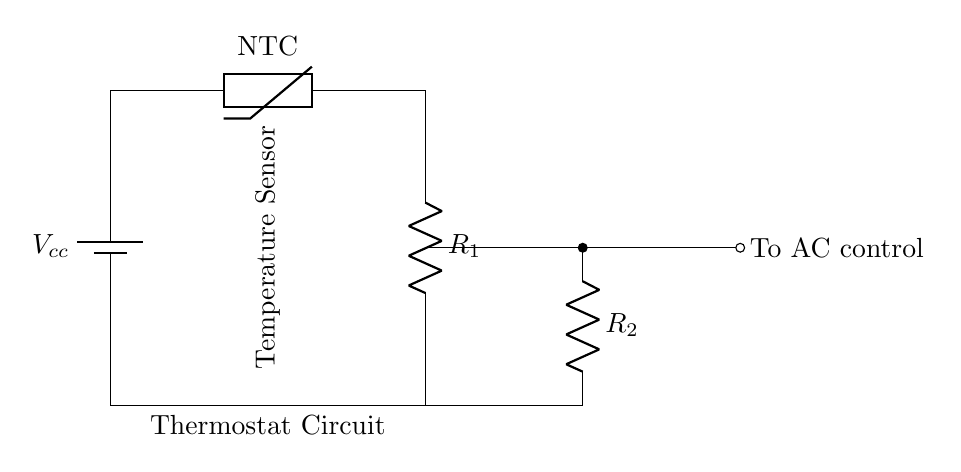What type of sensor is shown in the circuit? The circuit diagram includes a thermistor, which is a type of temperature sensor that changes its resistance with temperature.
Answer: thermistor What is the role of resistor R1 in this circuit? Resistor R1 forms a voltage divider with the thermistor, helping to determine the voltage that corresponds to a specific temperature reading.
Answer: voltage divider How many resistors are present in the circuit? There are two resistors in the circuit labeled as R1 and R2.
Answer: two What is the function of the short connection next to R2? The short connection allows for a direct path from the output of R2 to the air conditioning control unit, effectively activating it based on the temperature readings from the circuit.
Answer: to AC control What happens to the resistance of the thermistor when the temperature increases? As the temperature increases, the resistance of the NTC thermistor decreases, allowing more current to flow through and affecting the output signal to the AC control.
Answer: decreases What does the voltage labeled Vcc represent? Vcc represents the supply voltage provided to power the entire circuit, necessary for the operation of the components within the thermostat circuit.
Answer: supply voltage 